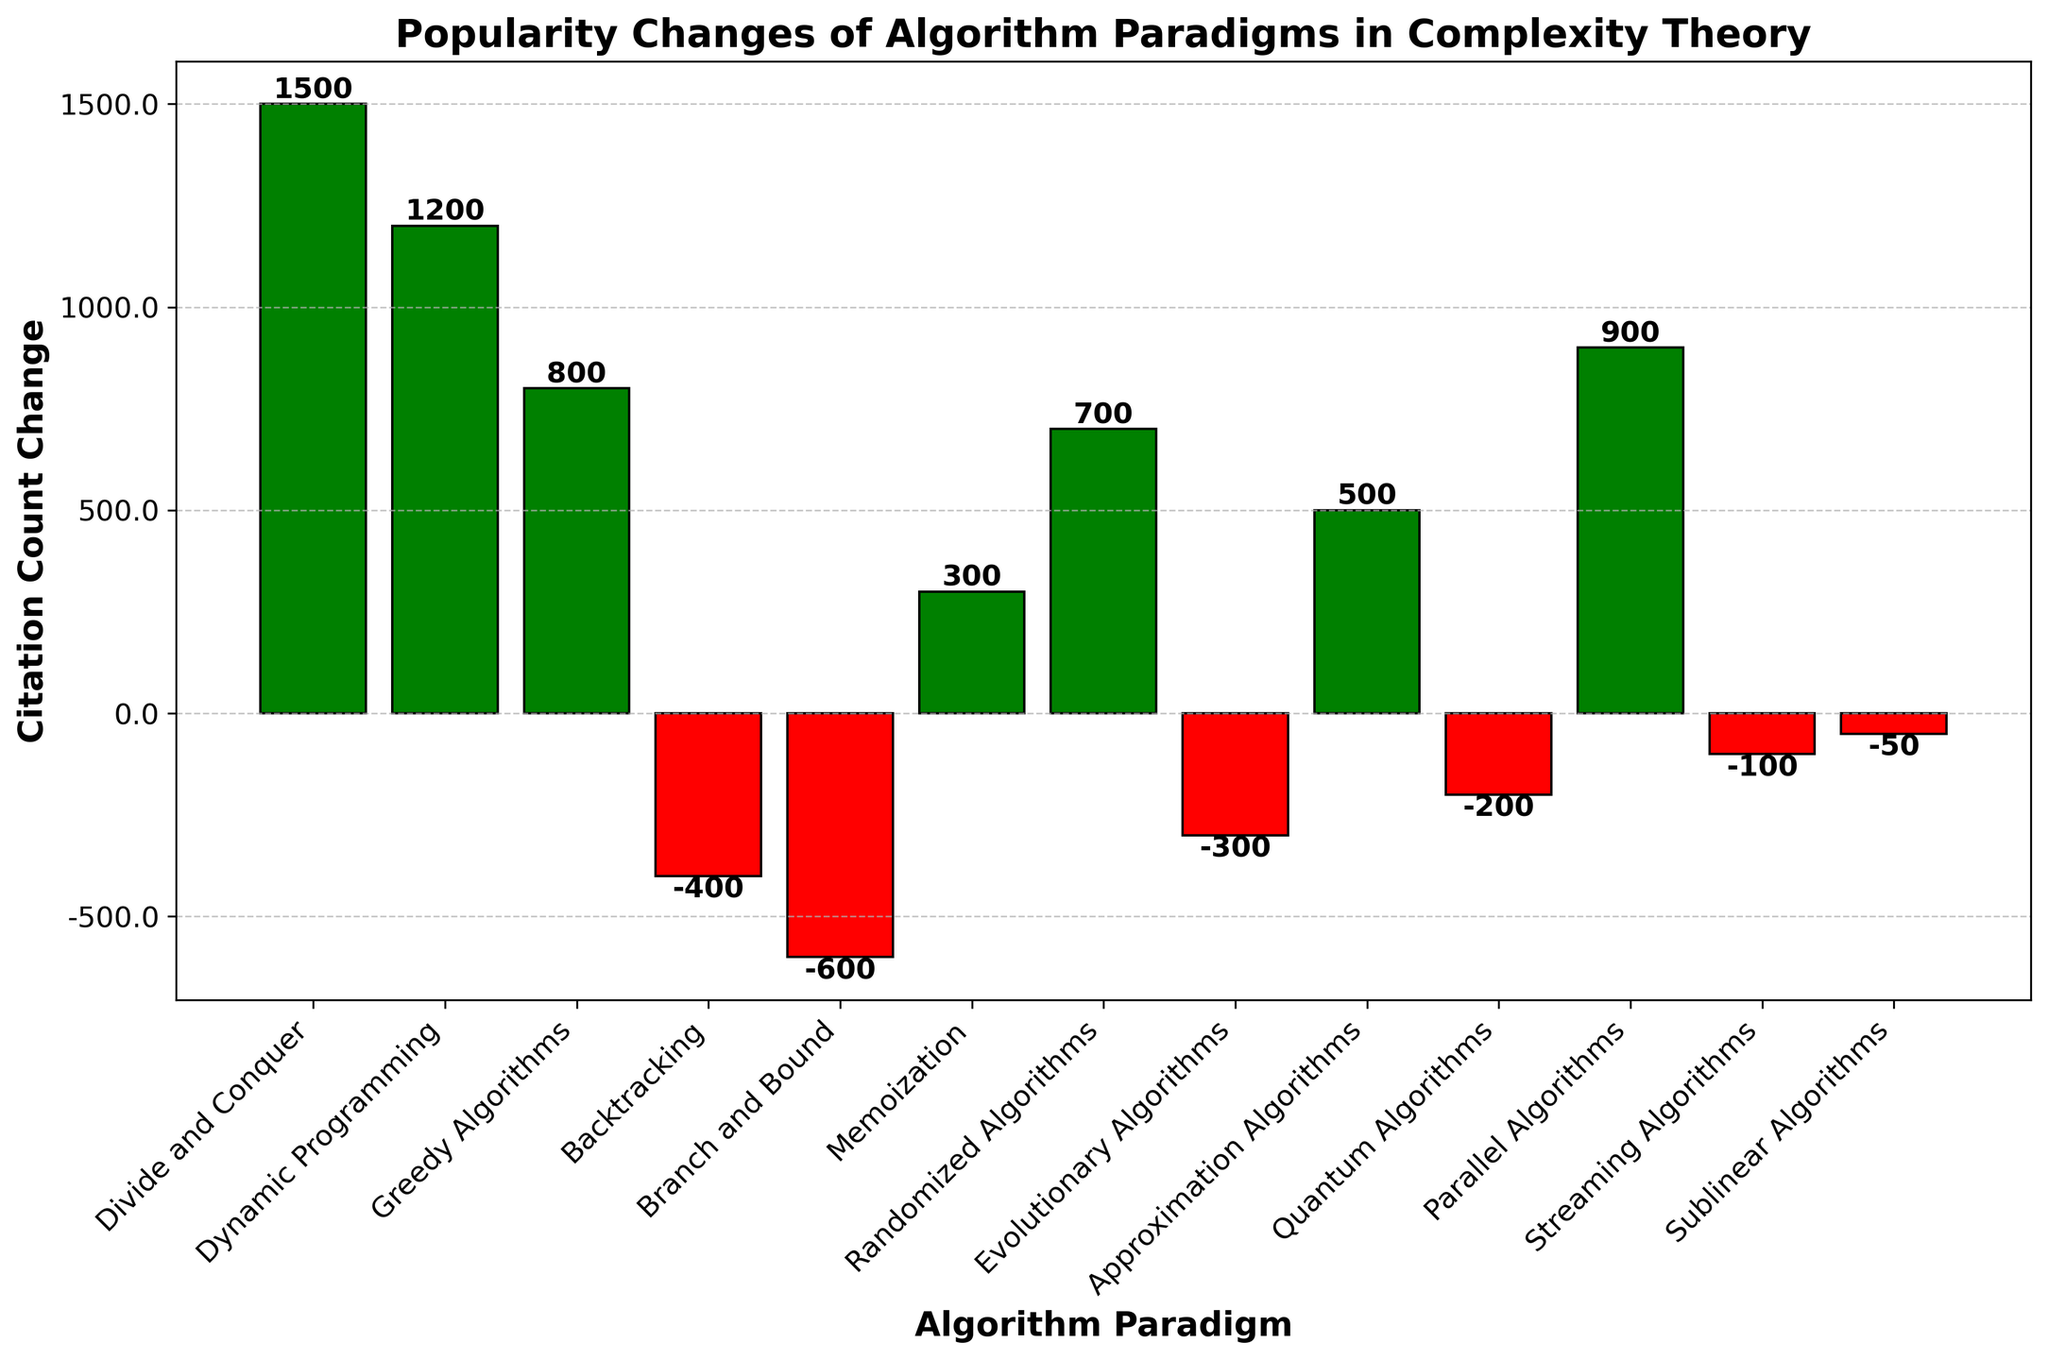What is the range of the citation count changes depicted in the figure? To find the range, identify the maximum and minimum values in the citation count change. The maximum value is for "Divide and Conquer" (1500) and the minimum value is for "Branch and Bound" (-600). The range is 1500 - (-600) = 2100.
Answer: 2100 Which algorithm paradigm has the smallest decline in popularity? Look for the paradigm with the smallest negative value. "Sublinear Algorithms" has the smallest decline with a citation count change of -50.
Answer: Sublinear Algorithms How many algorithm paradigms have experienced a decline in citations? Count the number of paradigms with negative citation count changes. There are five: "Backtracking," "Branch and Bound," "Evolutionary Algorithms," "Quantum Algorithms," and "Streaming Algorithms," "Sublinear Algorithms."
Answer: Six Which algorithm paradigms have the highest and the lowest positive citation count changes? The highest positive change is "Divide and Conquer" with 1500, and the lowest positive change is "Memoization" with 300.
Answer: Divide and Conquer, Memoization What is the total increase in citation counts for the paradigms with positive values? Sum the citation count changes for paradigms with positive values: 1500 + 1200 + 800 + 300 + 700 + 500 + 900 = 5900.
Answer: 5900 Compare the citation count changes between 'Dynamic Programming' and 'Randomized Algorithms'. Which has a higher change and by how much? "Dynamic Programming" has a count change of 1200, and "Randomized Algorithms" has 700. The difference is 1200 - 700 = 500, so "Dynamic Programming" is higher by 500.
Answer: Dynamic Programming by 500 What is the average citation count change for all paradigms depicted? Sum all the citation count changes and divide by the number of paradigms. Total sum is 1500 + 1200 + 800 - 400 - 600 + 300 + 700 - 300 + 500 - 200 + 900 - 100 - 50 = 5250, divided by 13 paradigms gives 5250 / 13 ≈ 403.85.
Answer: ~403.85 Which algorithm paradigms have citation count changes greater than the average citation count change? Calculate average change (403.85) and identify paradigms with changes above this value: "Divide and Conquer" (1500), "Dynamic Programming" (1200), "Greedy Algorithms" (800), "Parallel Algorithms" (900).
Answer: Divide and Conquer, Dynamic Programming, Greedy Algorithms, Parallel Algorithms Are there more algorithm paradigms with positive or negative changes? Count the paradigms with positive changes (7) and negative changes (6). There are more paradigms with positive changes.
Answer: Positive 